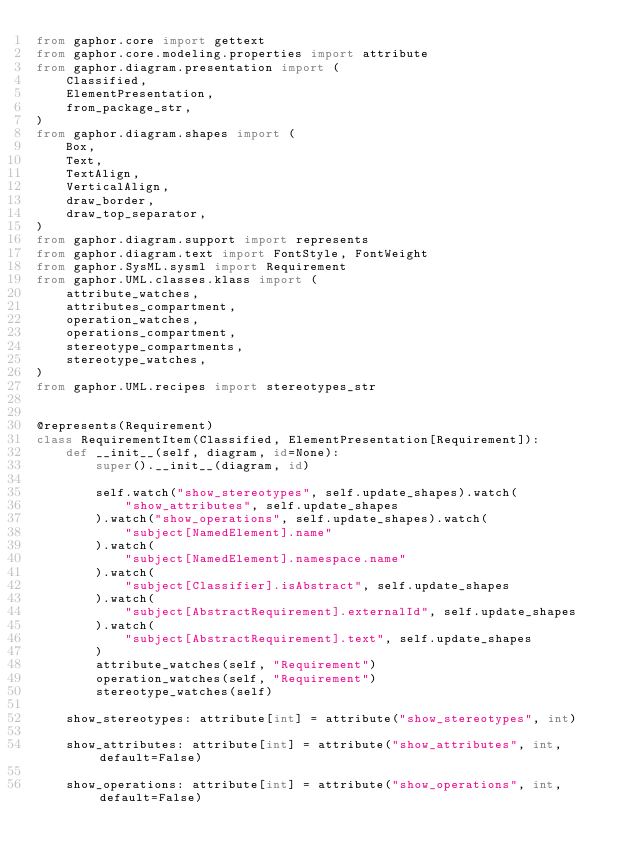Convert code to text. <code><loc_0><loc_0><loc_500><loc_500><_Python_>from gaphor.core import gettext
from gaphor.core.modeling.properties import attribute
from gaphor.diagram.presentation import (
    Classified,
    ElementPresentation,
    from_package_str,
)
from gaphor.diagram.shapes import (
    Box,
    Text,
    TextAlign,
    VerticalAlign,
    draw_border,
    draw_top_separator,
)
from gaphor.diagram.support import represents
from gaphor.diagram.text import FontStyle, FontWeight
from gaphor.SysML.sysml import Requirement
from gaphor.UML.classes.klass import (
    attribute_watches,
    attributes_compartment,
    operation_watches,
    operations_compartment,
    stereotype_compartments,
    stereotype_watches,
)
from gaphor.UML.recipes import stereotypes_str


@represents(Requirement)
class RequirementItem(Classified, ElementPresentation[Requirement]):
    def __init__(self, diagram, id=None):
        super().__init__(diagram, id)

        self.watch("show_stereotypes", self.update_shapes).watch(
            "show_attributes", self.update_shapes
        ).watch("show_operations", self.update_shapes).watch(
            "subject[NamedElement].name"
        ).watch(
            "subject[NamedElement].namespace.name"
        ).watch(
            "subject[Classifier].isAbstract", self.update_shapes
        ).watch(
            "subject[AbstractRequirement].externalId", self.update_shapes
        ).watch(
            "subject[AbstractRequirement].text", self.update_shapes
        )
        attribute_watches(self, "Requirement")
        operation_watches(self, "Requirement")
        stereotype_watches(self)

    show_stereotypes: attribute[int] = attribute("show_stereotypes", int)

    show_attributes: attribute[int] = attribute("show_attributes", int, default=False)

    show_operations: attribute[int] = attribute("show_operations", int, default=False)
</code> 